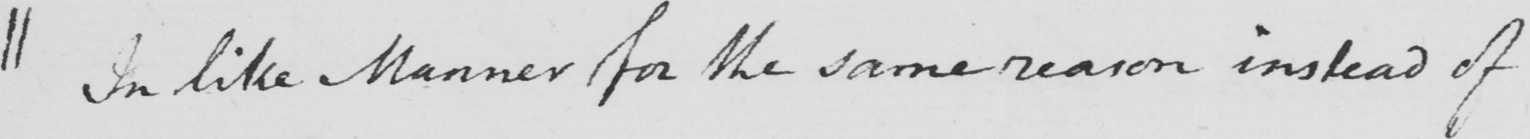Please provide the text content of this handwritten line. || In like Manner for the same reason instead of 